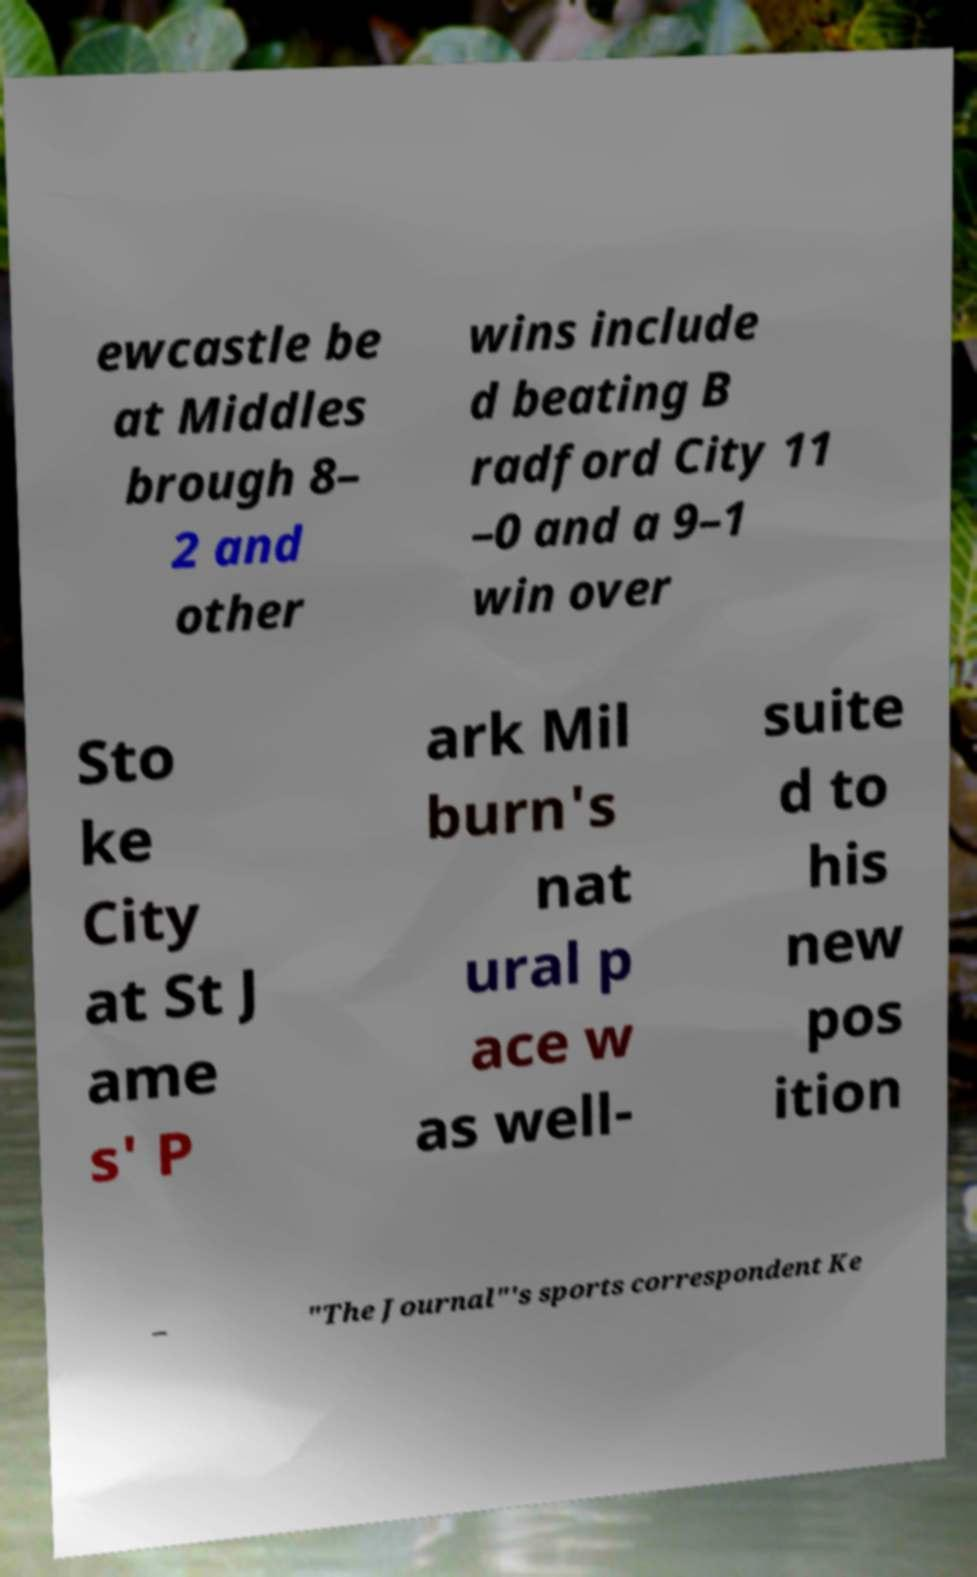Can you read and provide the text displayed in the image?This photo seems to have some interesting text. Can you extract and type it out for me? ewcastle be at Middles brough 8– 2 and other wins include d beating B radford City 11 –0 and a 9–1 win over Sto ke City at St J ame s' P ark Mil burn's nat ural p ace w as well- suite d to his new pos ition – "The Journal"'s sports correspondent Ke 